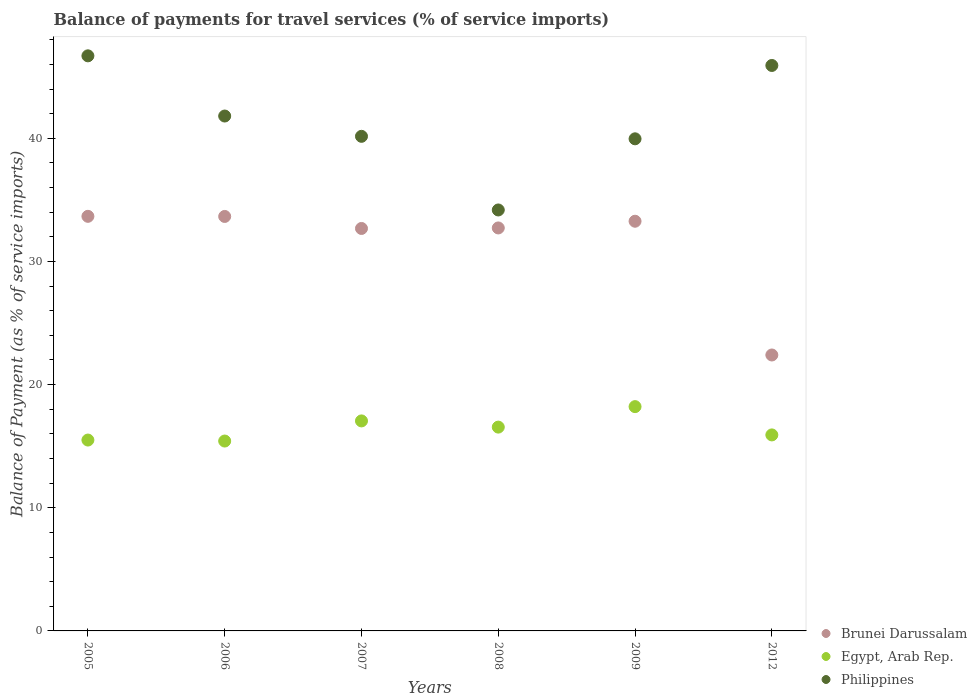How many different coloured dotlines are there?
Provide a succinct answer. 3. Is the number of dotlines equal to the number of legend labels?
Offer a terse response. Yes. What is the balance of payments for travel services in Brunei Darussalam in 2006?
Offer a terse response. 33.66. Across all years, what is the maximum balance of payments for travel services in Philippines?
Make the answer very short. 46.7. Across all years, what is the minimum balance of payments for travel services in Egypt, Arab Rep.?
Your answer should be compact. 15.42. In which year was the balance of payments for travel services in Philippines maximum?
Provide a succinct answer. 2005. In which year was the balance of payments for travel services in Egypt, Arab Rep. minimum?
Provide a succinct answer. 2006. What is the total balance of payments for travel services in Egypt, Arab Rep. in the graph?
Your answer should be very brief. 98.65. What is the difference between the balance of payments for travel services in Brunei Darussalam in 2006 and that in 2008?
Provide a succinct answer. 0.93. What is the difference between the balance of payments for travel services in Egypt, Arab Rep. in 2006 and the balance of payments for travel services in Philippines in 2012?
Your answer should be very brief. -30.5. What is the average balance of payments for travel services in Brunei Darussalam per year?
Provide a short and direct response. 31.4. In the year 2012, what is the difference between the balance of payments for travel services in Egypt, Arab Rep. and balance of payments for travel services in Brunei Darussalam?
Give a very brief answer. -6.49. What is the ratio of the balance of payments for travel services in Egypt, Arab Rep. in 2006 to that in 2012?
Give a very brief answer. 0.97. Is the balance of payments for travel services in Brunei Darussalam in 2007 less than that in 2012?
Offer a very short reply. No. Is the difference between the balance of payments for travel services in Egypt, Arab Rep. in 2006 and 2007 greater than the difference between the balance of payments for travel services in Brunei Darussalam in 2006 and 2007?
Make the answer very short. No. What is the difference between the highest and the second highest balance of payments for travel services in Philippines?
Provide a short and direct response. 0.78. What is the difference between the highest and the lowest balance of payments for travel services in Philippines?
Your answer should be very brief. 12.52. In how many years, is the balance of payments for travel services in Egypt, Arab Rep. greater than the average balance of payments for travel services in Egypt, Arab Rep. taken over all years?
Offer a terse response. 3. Is the sum of the balance of payments for travel services in Philippines in 2005 and 2007 greater than the maximum balance of payments for travel services in Brunei Darussalam across all years?
Offer a very short reply. Yes. Is the balance of payments for travel services in Philippines strictly greater than the balance of payments for travel services in Brunei Darussalam over the years?
Provide a short and direct response. Yes. How many dotlines are there?
Offer a very short reply. 3. How many years are there in the graph?
Offer a terse response. 6. What is the difference between two consecutive major ticks on the Y-axis?
Offer a terse response. 10. Does the graph contain any zero values?
Offer a very short reply. No. Where does the legend appear in the graph?
Provide a short and direct response. Bottom right. How are the legend labels stacked?
Offer a terse response. Vertical. What is the title of the graph?
Your answer should be very brief. Balance of payments for travel services (% of service imports). Does "Sub-Saharan Africa (developing only)" appear as one of the legend labels in the graph?
Ensure brevity in your answer.  No. What is the label or title of the Y-axis?
Offer a terse response. Balance of Payment (as % of service imports). What is the Balance of Payment (as % of service imports) in Brunei Darussalam in 2005?
Give a very brief answer. 33.67. What is the Balance of Payment (as % of service imports) in Egypt, Arab Rep. in 2005?
Ensure brevity in your answer.  15.5. What is the Balance of Payment (as % of service imports) of Philippines in 2005?
Offer a terse response. 46.7. What is the Balance of Payment (as % of service imports) of Brunei Darussalam in 2006?
Give a very brief answer. 33.66. What is the Balance of Payment (as % of service imports) of Egypt, Arab Rep. in 2006?
Your answer should be compact. 15.42. What is the Balance of Payment (as % of service imports) in Philippines in 2006?
Make the answer very short. 41.81. What is the Balance of Payment (as % of service imports) of Brunei Darussalam in 2007?
Offer a very short reply. 32.68. What is the Balance of Payment (as % of service imports) in Egypt, Arab Rep. in 2007?
Give a very brief answer. 17.05. What is the Balance of Payment (as % of service imports) of Philippines in 2007?
Offer a very short reply. 40.16. What is the Balance of Payment (as % of service imports) in Brunei Darussalam in 2008?
Provide a short and direct response. 32.72. What is the Balance of Payment (as % of service imports) in Egypt, Arab Rep. in 2008?
Provide a short and direct response. 16.55. What is the Balance of Payment (as % of service imports) in Philippines in 2008?
Ensure brevity in your answer.  34.18. What is the Balance of Payment (as % of service imports) of Brunei Darussalam in 2009?
Your response must be concise. 33.27. What is the Balance of Payment (as % of service imports) of Egypt, Arab Rep. in 2009?
Offer a very short reply. 18.21. What is the Balance of Payment (as % of service imports) in Philippines in 2009?
Give a very brief answer. 39.96. What is the Balance of Payment (as % of service imports) in Brunei Darussalam in 2012?
Ensure brevity in your answer.  22.41. What is the Balance of Payment (as % of service imports) of Egypt, Arab Rep. in 2012?
Keep it short and to the point. 15.92. What is the Balance of Payment (as % of service imports) of Philippines in 2012?
Your response must be concise. 45.92. Across all years, what is the maximum Balance of Payment (as % of service imports) of Brunei Darussalam?
Give a very brief answer. 33.67. Across all years, what is the maximum Balance of Payment (as % of service imports) in Egypt, Arab Rep.?
Your response must be concise. 18.21. Across all years, what is the maximum Balance of Payment (as % of service imports) of Philippines?
Provide a succinct answer. 46.7. Across all years, what is the minimum Balance of Payment (as % of service imports) in Brunei Darussalam?
Provide a succinct answer. 22.41. Across all years, what is the minimum Balance of Payment (as % of service imports) of Egypt, Arab Rep.?
Make the answer very short. 15.42. Across all years, what is the minimum Balance of Payment (as % of service imports) of Philippines?
Make the answer very short. 34.18. What is the total Balance of Payment (as % of service imports) in Brunei Darussalam in the graph?
Provide a short and direct response. 188.4. What is the total Balance of Payment (as % of service imports) of Egypt, Arab Rep. in the graph?
Your answer should be compact. 98.65. What is the total Balance of Payment (as % of service imports) in Philippines in the graph?
Provide a succinct answer. 248.73. What is the difference between the Balance of Payment (as % of service imports) of Brunei Darussalam in 2005 and that in 2006?
Offer a very short reply. 0.01. What is the difference between the Balance of Payment (as % of service imports) of Egypt, Arab Rep. in 2005 and that in 2006?
Provide a short and direct response. 0.08. What is the difference between the Balance of Payment (as % of service imports) in Philippines in 2005 and that in 2006?
Your response must be concise. 4.89. What is the difference between the Balance of Payment (as % of service imports) of Brunei Darussalam in 2005 and that in 2007?
Your response must be concise. 0.99. What is the difference between the Balance of Payment (as % of service imports) of Egypt, Arab Rep. in 2005 and that in 2007?
Make the answer very short. -1.55. What is the difference between the Balance of Payment (as % of service imports) in Philippines in 2005 and that in 2007?
Your answer should be very brief. 6.54. What is the difference between the Balance of Payment (as % of service imports) of Brunei Darussalam in 2005 and that in 2008?
Offer a very short reply. 0.94. What is the difference between the Balance of Payment (as % of service imports) of Egypt, Arab Rep. in 2005 and that in 2008?
Ensure brevity in your answer.  -1.05. What is the difference between the Balance of Payment (as % of service imports) in Philippines in 2005 and that in 2008?
Make the answer very short. 12.52. What is the difference between the Balance of Payment (as % of service imports) in Brunei Darussalam in 2005 and that in 2009?
Your answer should be compact. 0.4. What is the difference between the Balance of Payment (as % of service imports) of Egypt, Arab Rep. in 2005 and that in 2009?
Make the answer very short. -2.71. What is the difference between the Balance of Payment (as % of service imports) of Philippines in 2005 and that in 2009?
Provide a succinct answer. 6.74. What is the difference between the Balance of Payment (as % of service imports) of Brunei Darussalam in 2005 and that in 2012?
Keep it short and to the point. 11.26. What is the difference between the Balance of Payment (as % of service imports) of Egypt, Arab Rep. in 2005 and that in 2012?
Your response must be concise. -0.42. What is the difference between the Balance of Payment (as % of service imports) in Philippines in 2005 and that in 2012?
Make the answer very short. 0.78. What is the difference between the Balance of Payment (as % of service imports) of Brunei Darussalam in 2006 and that in 2007?
Provide a short and direct response. 0.98. What is the difference between the Balance of Payment (as % of service imports) in Egypt, Arab Rep. in 2006 and that in 2007?
Your answer should be compact. -1.63. What is the difference between the Balance of Payment (as % of service imports) in Philippines in 2006 and that in 2007?
Keep it short and to the point. 1.65. What is the difference between the Balance of Payment (as % of service imports) of Egypt, Arab Rep. in 2006 and that in 2008?
Provide a short and direct response. -1.13. What is the difference between the Balance of Payment (as % of service imports) in Philippines in 2006 and that in 2008?
Offer a very short reply. 7.63. What is the difference between the Balance of Payment (as % of service imports) of Brunei Darussalam in 2006 and that in 2009?
Ensure brevity in your answer.  0.39. What is the difference between the Balance of Payment (as % of service imports) in Egypt, Arab Rep. in 2006 and that in 2009?
Provide a succinct answer. -2.79. What is the difference between the Balance of Payment (as % of service imports) in Philippines in 2006 and that in 2009?
Ensure brevity in your answer.  1.85. What is the difference between the Balance of Payment (as % of service imports) in Brunei Darussalam in 2006 and that in 2012?
Make the answer very short. 11.25. What is the difference between the Balance of Payment (as % of service imports) of Egypt, Arab Rep. in 2006 and that in 2012?
Your response must be concise. -0.5. What is the difference between the Balance of Payment (as % of service imports) of Philippines in 2006 and that in 2012?
Make the answer very short. -4.11. What is the difference between the Balance of Payment (as % of service imports) in Brunei Darussalam in 2007 and that in 2008?
Ensure brevity in your answer.  -0.04. What is the difference between the Balance of Payment (as % of service imports) of Egypt, Arab Rep. in 2007 and that in 2008?
Make the answer very short. 0.5. What is the difference between the Balance of Payment (as % of service imports) of Philippines in 2007 and that in 2008?
Your answer should be very brief. 5.98. What is the difference between the Balance of Payment (as % of service imports) in Brunei Darussalam in 2007 and that in 2009?
Your response must be concise. -0.59. What is the difference between the Balance of Payment (as % of service imports) of Egypt, Arab Rep. in 2007 and that in 2009?
Your answer should be compact. -1.16. What is the difference between the Balance of Payment (as % of service imports) in Philippines in 2007 and that in 2009?
Your answer should be compact. 0.2. What is the difference between the Balance of Payment (as % of service imports) of Brunei Darussalam in 2007 and that in 2012?
Offer a very short reply. 10.27. What is the difference between the Balance of Payment (as % of service imports) of Egypt, Arab Rep. in 2007 and that in 2012?
Ensure brevity in your answer.  1.14. What is the difference between the Balance of Payment (as % of service imports) in Philippines in 2007 and that in 2012?
Your answer should be very brief. -5.75. What is the difference between the Balance of Payment (as % of service imports) of Brunei Darussalam in 2008 and that in 2009?
Your response must be concise. -0.54. What is the difference between the Balance of Payment (as % of service imports) of Egypt, Arab Rep. in 2008 and that in 2009?
Provide a short and direct response. -1.66. What is the difference between the Balance of Payment (as % of service imports) in Philippines in 2008 and that in 2009?
Offer a very short reply. -5.78. What is the difference between the Balance of Payment (as % of service imports) of Brunei Darussalam in 2008 and that in 2012?
Ensure brevity in your answer.  10.32. What is the difference between the Balance of Payment (as % of service imports) in Egypt, Arab Rep. in 2008 and that in 2012?
Ensure brevity in your answer.  0.63. What is the difference between the Balance of Payment (as % of service imports) in Philippines in 2008 and that in 2012?
Your response must be concise. -11.73. What is the difference between the Balance of Payment (as % of service imports) of Brunei Darussalam in 2009 and that in 2012?
Keep it short and to the point. 10.86. What is the difference between the Balance of Payment (as % of service imports) in Egypt, Arab Rep. in 2009 and that in 2012?
Offer a very short reply. 2.3. What is the difference between the Balance of Payment (as % of service imports) of Philippines in 2009 and that in 2012?
Offer a very short reply. -5.96. What is the difference between the Balance of Payment (as % of service imports) of Brunei Darussalam in 2005 and the Balance of Payment (as % of service imports) of Egypt, Arab Rep. in 2006?
Keep it short and to the point. 18.25. What is the difference between the Balance of Payment (as % of service imports) in Brunei Darussalam in 2005 and the Balance of Payment (as % of service imports) in Philippines in 2006?
Your answer should be compact. -8.14. What is the difference between the Balance of Payment (as % of service imports) in Egypt, Arab Rep. in 2005 and the Balance of Payment (as % of service imports) in Philippines in 2006?
Your answer should be compact. -26.31. What is the difference between the Balance of Payment (as % of service imports) of Brunei Darussalam in 2005 and the Balance of Payment (as % of service imports) of Egypt, Arab Rep. in 2007?
Provide a succinct answer. 16.61. What is the difference between the Balance of Payment (as % of service imports) in Brunei Darussalam in 2005 and the Balance of Payment (as % of service imports) in Philippines in 2007?
Your answer should be very brief. -6.5. What is the difference between the Balance of Payment (as % of service imports) in Egypt, Arab Rep. in 2005 and the Balance of Payment (as % of service imports) in Philippines in 2007?
Your response must be concise. -24.66. What is the difference between the Balance of Payment (as % of service imports) in Brunei Darussalam in 2005 and the Balance of Payment (as % of service imports) in Egypt, Arab Rep. in 2008?
Give a very brief answer. 17.12. What is the difference between the Balance of Payment (as % of service imports) of Brunei Darussalam in 2005 and the Balance of Payment (as % of service imports) of Philippines in 2008?
Ensure brevity in your answer.  -0.52. What is the difference between the Balance of Payment (as % of service imports) of Egypt, Arab Rep. in 2005 and the Balance of Payment (as % of service imports) of Philippines in 2008?
Offer a terse response. -18.68. What is the difference between the Balance of Payment (as % of service imports) of Brunei Darussalam in 2005 and the Balance of Payment (as % of service imports) of Egypt, Arab Rep. in 2009?
Make the answer very short. 15.45. What is the difference between the Balance of Payment (as % of service imports) in Brunei Darussalam in 2005 and the Balance of Payment (as % of service imports) in Philippines in 2009?
Your response must be concise. -6.29. What is the difference between the Balance of Payment (as % of service imports) in Egypt, Arab Rep. in 2005 and the Balance of Payment (as % of service imports) in Philippines in 2009?
Give a very brief answer. -24.46. What is the difference between the Balance of Payment (as % of service imports) of Brunei Darussalam in 2005 and the Balance of Payment (as % of service imports) of Egypt, Arab Rep. in 2012?
Make the answer very short. 17.75. What is the difference between the Balance of Payment (as % of service imports) in Brunei Darussalam in 2005 and the Balance of Payment (as % of service imports) in Philippines in 2012?
Provide a succinct answer. -12.25. What is the difference between the Balance of Payment (as % of service imports) of Egypt, Arab Rep. in 2005 and the Balance of Payment (as % of service imports) of Philippines in 2012?
Keep it short and to the point. -30.42. What is the difference between the Balance of Payment (as % of service imports) of Brunei Darussalam in 2006 and the Balance of Payment (as % of service imports) of Egypt, Arab Rep. in 2007?
Ensure brevity in your answer.  16.6. What is the difference between the Balance of Payment (as % of service imports) of Brunei Darussalam in 2006 and the Balance of Payment (as % of service imports) of Philippines in 2007?
Make the answer very short. -6.51. What is the difference between the Balance of Payment (as % of service imports) of Egypt, Arab Rep. in 2006 and the Balance of Payment (as % of service imports) of Philippines in 2007?
Provide a short and direct response. -24.74. What is the difference between the Balance of Payment (as % of service imports) in Brunei Darussalam in 2006 and the Balance of Payment (as % of service imports) in Egypt, Arab Rep. in 2008?
Give a very brief answer. 17.11. What is the difference between the Balance of Payment (as % of service imports) in Brunei Darussalam in 2006 and the Balance of Payment (as % of service imports) in Philippines in 2008?
Make the answer very short. -0.53. What is the difference between the Balance of Payment (as % of service imports) in Egypt, Arab Rep. in 2006 and the Balance of Payment (as % of service imports) in Philippines in 2008?
Ensure brevity in your answer.  -18.76. What is the difference between the Balance of Payment (as % of service imports) in Brunei Darussalam in 2006 and the Balance of Payment (as % of service imports) in Egypt, Arab Rep. in 2009?
Your answer should be very brief. 15.44. What is the difference between the Balance of Payment (as % of service imports) in Brunei Darussalam in 2006 and the Balance of Payment (as % of service imports) in Philippines in 2009?
Offer a terse response. -6.3. What is the difference between the Balance of Payment (as % of service imports) of Egypt, Arab Rep. in 2006 and the Balance of Payment (as % of service imports) of Philippines in 2009?
Offer a very short reply. -24.54. What is the difference between the Balance of Payment (as % of service imports) in Brunei Darussalam in 2006 and the Balance of Payment (as % of service imports) in Egypt, Arab Rep. in 2012?
Give a very brief answer. 17.74. What is the difference between the Balance of Payment (as % of service imports) of Brunei Darussalam in 2006 and the Balance of Payment (as % of service imports) of Philippines in 2012?
Make the answer very short. -12.26. What is the difference between the Balance of Payment (as % of service imports) in Egypt, Arab Rep. in 2006 and the Balance of Payment (as % of service imports) in Philippines in 2012?
Make the answer very short. -30.5. What is the difference between the Balance of Payment (as % of service imports) in Brunei Darussalam in 2007 and the Balance of Payment (as % of service imports) in Egypt, Arab Rep. in 2008?
Offer a very short reply. 16.13. What is the difference between the Balance of Payment (as % of service imports) of Brunei Darussalam in 2007 and the Balance of Payment (as % of service imports) of Philippines in 2008?
Provide a short and direct response. -1.5. What is the difference between the Balance of Payment (as % of service imports) in Egypt, Arab Rep. in 2007 and the Balance of Payment (as % of service imports) in Philippines in 2008?
Provide a short and direct response. -17.13. What is the difference between the Balance of Payment (as % of service imports) of Brunei Darussalam in 2007 and the Balance of Payment (as % of service imports) of Egypt, Arab Rep. in 2009?
Ensure brevity in your answer.  14.47. What is the difference between the Balance of Payment (as % of service imports) of Brunei Darussalam in 2007 and the Balance of Payment (as % of service imports) of Philippines in 2009?
Your answer should be compact. -7.28. What is the difference between the Balance of Payment (as % of service imports) of Egypt, Arab Rep. in 2007 and the Balance of Payment (as % of service imports) of Philippines in 2009?
Ensure brevity in your answer.  -22.91. What is the difference between the Balance of Payment (as % of service imports) of Brunei Darussalam in 2007 and the Balance of Payment (as % of service imports) of Egypt, Arab Rep. in 2012?
Keep it short and to the point. 16.76. What is the difference between the Balance of Payment (as % of service imports) in Brunei Darussalam in 2007 and the Balance of Payment (as % of service imports) in Philippines in 2012?
Offer a terse response. -13.24. What is the difference between the Balance of Payment (as % of service imports) of Egypt, Arab Rep. in 2007 and the Balance of Payment (as % of service imports) of Philippines in 2012?
Make the answer very short. -28.86. What is the difference between the Balance of Payment (as % of service imports) in Brunei Darussalam in 2008 and the Balance of Payment (as % of service imports) in Egypt, Arab Rep. in 2009?
Keep it short and to the point. 14.51. What is the difference between the Balance of Payment (as % of service imports) in Brunei Darussalam in 2008 and the Balance of Payment (as % of service imports) in Philippines in 2009?
Provide a short and direct response. -7.24. What is the difference between the Balance of Payment (as % of service imports) in Egypt, Arab Rep. in 2008 and the Balance of Payment (as % of service imports) in Philippines in 2009?
Your answer should be compact. -23.41. What is the difference between the Balance of Payment (as % of service imports) of Brunei Darussalam in 2008 and the Balance of Payment (as % of service imports) of Egypt, Arab Rep. in 2012?
Your answer should be compact. 16.81. What is the difference between the Balance of Payment (as % of service imports) of Brunei Darussalam in 2008 and the Balance of Payment (as % of service imports) of Philippines in 2012?
Ensure brevity in your answer.  -13.19. What is the difference between the Balance of Payment (as % of service imports) of Egypt, Arab Rep. in 2008 and the Balance of Payment (as % of service imports) of Philippines in 2012?
Provide a short and direct response. -29.37. What is the difference between the Balance of Payment (as % of service imports) in Brunei Darussalam in 2009 and the Balance of Payment (as % of service imports) in Egypt, Arab Rep. in 2012?
Provide a succinct answer. 17.35. What is the difference between the Balance of Payment (as % of service imports) in Brunei Darussalam in 2009 and the Balance of Payment (as % of service imports) in Philippines in 2012?
Your answer should be very brief. -12.65. What is the difference between the Balance of Payment (as % of service imports) of Egypt, Arab Rep. in 2009 and the Balance of Payment (as % of service imports) of Philippines in 2012?
Offer a very short reply. -27.7. What is the average Balance of Payment (as % of service imports) in Brunei Darussalam per year?
Ensure brevity in your answer.  31.4. What is the average Balance of Payment (as % of service imports) of Egypt, Arab Rep. per year?
Your answer should be very brief. 16.44. What is the average Balance of Payment (as % of service imports) in Philippines per year?
Ensure brevity in your answer.  41.46. In the year 2005, what is the difference between the Balance of Payment (as % of service imports) in Brunei Darussalam and Balance of Payment (as % of service imports) in Egypt, Arab Rep.?
Your answer should be compact. 18.17. In the year 2005, what is the difference between the Balance of Payment (as % of service imports) in Brunei Darussalam and Balance of Payment (as % of service imports) in Philippines?
Make the answer very short. -13.03. In the year 2005, what is the difference between the Balance of Payment (as % of service imports) in Egypt, Arab Rep. and Balance of Payment (as % of service imports) in Philippines?
Your response must be concise. -31.2. In the year 2006, what is the difference between the Balance of Payment (as % of service imports) of Brunei Darussalam and Balance of Payment (as % of service imports) of Egypt, Arab Rep.?
Provide a succinct answer. 18.24. In the year 2006, what is the difference between the Balance of Payment (as % of service imports) in Brunei Darussalam and Balance of Payment (as % of service imports) in Philippines?
Give a very brief answer. -8.15. In the year 2006, what is the difference between the Balance of Payment (as % of service imports) of Egypt, Arab Rep. and Balance of Payment (as % of service imports) of Philippines?
Provide a succinct answer. -26.39. In the year 2007, what is the difference between the Balance of Payment (as % of service imports) in Brunei Darussalam and Balance of Payment (as % of service imports) in Egypt, Arab Rep.?
Offer a terse response. 15.63. In the year 2007, what is the difference between the Balance of Payment (as % of service imports) in Brunei Darussalam and Balance of Payment (as % of service imports) in Philippines?
Offer a terse response. -7.48. In the year 2007, what is the difference between the Balance of Payment (as % of service imports) in Egypt, Arab Rep. and Balance of Payment (as % of service imports) in Philippines?
Provide a short and direct response. -23.11. In the year 2008, what is the difference between the Balance of Payment (as % of service imports) in Brunei Darussalam and Balance of Payment (as % of service imports) in Egypt, Arab Rep.?
Offer a very short reply. 16.17. In the year 2008, what is the difference between the Balance of Payment (as % of service imports) in Brunei Darussalam and Balance of Payment (as % of service imports) in Philippines?
Your answer should be very brief. -1.46. In the year 2008, what is the difference between the Balance of Payment (as % of service imports) in Egypt, Arab Rep. and Balance of Payment (as % of service imports) in Philippines?
Provide a succinct answer. -17.63. In the year 2009, what is the difference between the Balance of Payment (as % of service imports) of Brunei Darussalam and Balance of Payment (as % of service imports) of Egypt, Arab Rep.?
Your answer should be very brief. 15.05. In the year 2009, what is the difference between the Balance of Payment (as % of service imports) of Brunei Darussalam and Balance of Payment (as % of service imports) of Philippines?
Provide a succinct answer. -6.69. In the year 2009, what is the difference between the Balance of Payment (as % of service imports) in Egypt, Arab Rep. and Balance of Payment (as % of service imports) in Philippines?
Offer a terse response. -21.75. In the year 2012, what is the difference between the Balance of Payment (as % of service imports) of Brunei Darussalam and Balance of Payment (as % of service imports) of Egypt, Arab Rep.?
Your answer should be compact. 6.49. In the year 2012, what is the difference between the Balance of Payment (as % of service imports) in Brunei Darussalam and Balance of Payment (as % of service imports) in Philippines?
Provide a short and direct response. -23.51. In the year 2012, what is the difference between the Balance of Payment (as % of service imports) in Egypt, Arab Rep. and Balance of Payment (as % of service imports) in Philippines?
Offer a terse response. -30. What is the ratio of the Balance of Payment (as % of service imports) of Philippines in 2005 to that in 2006?
Provide a succinct answer. 1.12. What is the ratio of the Balance of Payment (as % of service imports) in Brunei Darussalam in 2005 to that in 2007?
Give a very brief answer. 1.03. What is the ratio of the Balance of Payment (as % of service imports) of Egypt, Arab Rep. in 2005 to that in 2007?
Provide a short and direct response. 0.91. What is the ratio of the Balance of Payment (as % of service imports) in Philippines in 2005 to that in 2007?
Make the answer very short. 1.16. What is the ratio of the Balance of Payment (as % of service imports) of Brunei Darussalam in 2005 to that in 2008?
Keep it short and to the point. 1.03. What is the ratio of the Balance of Payment (as % of service imports) of Egypt, Arab Rep. in 2005 to that in 2008?
Ensure brevity in your answer.  0.94. What is the ratio of the Balance of Payment (as % of service imports) of Philippines in 2005 to that in 2008?
Your answer should be compact. 1.37. What is the ratio of the Balance of Payment (as % of service imports) in Brunei Darussalam in 2005 to that in 2009?
Make the answer very short. 1.01. What is the ratio of the Balance of Payment (as % of service imports) in Egypt, Arab Rep. in 2005 to that in 2009?
Provide a short and direct response. 0.85. What is the ratio of the Balance of Payment (as % of service imports) of Philippines in 2005 to that in 2009?
Keep it short and to the point. 1.17. What is the ratio of the Balance of Payment (as % of service imports) in Brunei Darussalam in 2005 to that in 2012?
Your answer should be compact. 1.5. What is the ratio of the Balance of Payment (as % of service imports) in Egypt, Arab Rep. in 2005 to that in 2012?
Your answer should be very brief. 0.97. What is the ratio of the Balance of Payment (as % of service imports) of Philippines in 2005 to that in 2012?
Your answer should be very brief. 1.02. What is the ratio of the Balance of Payment (as % of service imports) in Brunei Darussalam in 2006 to that in 2007?
Keep it short and to the point. 1.03. What is the ratio of the Balance of Payment (as % of service imports) in Egypt, Arab Rep. in 2006 to that in 2007?
Your answer should be compact. 0.9. What is the ratio of the Balance of Payment (as % of service imports) in Philippines in 2006 to that in 2007?
Your answer should be compact. 1.04. What is the ratio of the Balance of Payment (as % of service imports) of Brunei Darussalam in 2006 to that in 2008?
Give a very brief answer. 1.03. What is the ratio of the Balance of Payment (as % of service imports) of Egypt, Arab Rep. in 2006 to that in 2008?
Give a very brief answer. 0.93. What is the ratio of the Balance of Payment (as % of service imports) in Philippines in 2006 to that in 2008?
Offer a very short reply. 1.22. What is the ratio of the Balance of Payment (as % of service imports) of Brunei Darussalam in 2006 to that in 2009?
Give a very brief answer. 1.01. What is the ratio of the Balance of Payment (as % of service imports) of Egypt, Arab Rep. in 2006 to that in 2009?
Your response must be concise. 0.85. What is the ratio of the Balance of Payment (as % of service imports) in Philippines in 2006 to that in 2009?
Give a very brief answer. 1.05. What is the ratio of the Balance of Payment (as % of service imports) of Brunei Darussalam in 2006 to that in 2012?
Provide a succinct answer. 1.5. What is the ratio of the Balance of Payment (as % of service imports) of Egypt, Arab Rep. in 2006 to that in 2012?
Offer a terse response. 0.97. What is the ratio of the Balance of Payment (as % of service imports) of Philippines in 2006 to that in 2012?
Your answer should be compact. 0.91. What is the ratio of the Balance of Payment (as % of service imports) of Egypt, Arab Rep. in 2007 to that in 2008?
Offer a terse response. 1.03. What is the ratio of the Balance of Payment (as % of service imports) of Philippines in 2007 to that in 2008?
Keep it short and to the point. 1.17. What is the ratio of the Balance of Payment (as % of service imports) of Brunei Darussalam in 2007 to that in 2009?
Provide a short and direct response. 0.98. What is the ratio of the Balance of Payment (as % of service imports) in Egypt, Arab Rep. in 2007 to that in 2009?
Ensure brevity in your answer.  0.94. What is the ratio of the Balance of Payment (as % of service imports) in Philippines in 2007 to that in 2009?
Keep it short and to the point. 1. What is the ratio of the Balance of Payment (as % of service imports) in Brunei Darussalam in 2007 to that in 2012?
Provide a short and direct response. 1.46. What is the ratio of the Balance of Payment (as % of service imports) in Egypt, Arab Rep. in 2007 to that in 2012?
Offer a terse response. 1.07. What is the ratio of the Balance of Payment (as % of service imports) of Philippines in 2007 to that in 2012?
Provide a short and direct response. 0.87. What is the ratio of the Balance of Payment (as % of service imports) in Brunei Darussalam in 2008 to that in 2009?
Make the answer very short. 0.98. What is the ratio of the Balance of Payment (as % of service imports) of Egypt, Arab Rep. in 2008 to that in 2009?
Your answer should be compact. 0.91. What is the ratio of the Balance of Payment (as % of service imports) in Philippines in 2008 to that in 2009?
Ensure brevity in your answer.  0.86. What is the ratio of the Balance of Payment (as % of service imports) of Brunei Darussalam in 2008 to that in 2012?
Ensure brevity in your answer.  1.46. What is the ratio of the Balance of Payment (as % of service imports) in Egypt, Arab Rep. in 2008 to that in 2012?
Offer a very short reply. 1.04. What is the ratio of the Balance of Payment (as % of service imports) in Philippines in 2008 to that in 2012?
Your response must be concise. 0.74. What is the ratio of the Balance of Payment (as % of service imports) of Brunei Darussalam in 2009 to that in 2012?
Your response must be concise. 1.48. What is the ratio of the Balance of Payment (as % of service imports) of Egypt, Arab Rep. in 2009 to that in 2012?
Make the answer very short. 1.14. What is the ratio of the Balance of Payment (as % of service imports) in Philippines in 2009 to that in 2012?
Your answer should be very brief. 0.87. What is the difference between the highest and the second highest Balance of Payment (as % of service imports) of Brunei Darussalam?
Keep it short and to the point. 0.01. What is the difference between the highest and the second highest Balance of Payment (as % of service imports) in Egypt, Arab Rep.?
Give a very brief answer. 1.16. What is the difference between the highest and the second highest Balance of Payment (as % of service imports) of Philippines?
Provide a succinct answer. 0.78. What is the difference between the highest and the lowest Balance of Payment (as % of service imports) in Brunei Darussalam?
Give a very brief answer. 11.26. What is the difference between the highest and the lowest Balance of Payment (as % of service imports) of Egypt, Arab Rep.?
Offer a very short reply. 2.79. What is the difference between the highest and the lowest Balance of Payment (as % of service imports) of Philippines?
Your response must be concise. 12.52. 